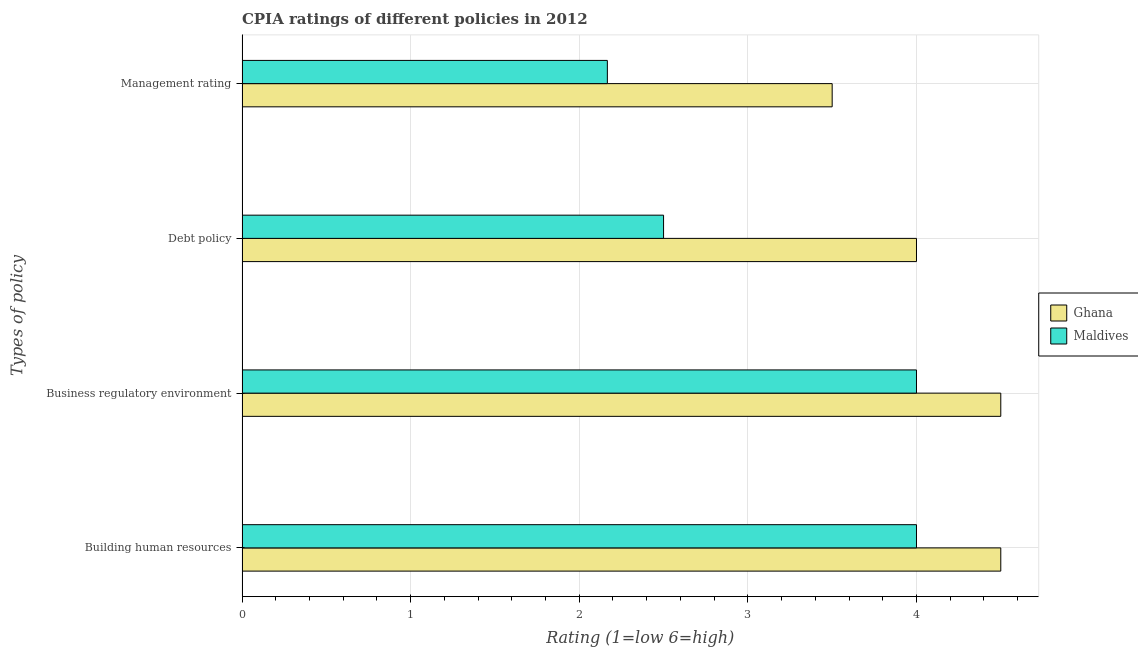How many different coloured bars are there?
Make the answer very short. 2. How many groups of bars are there?
Give a very brief answer. 4. Are the number of bars per tick equal to the number of legend labels?
Provide a short and direct response. Yes. How many bars are there on the 1st tick from the bottom?
Keep it short and to the point. 2. What is the label of the 3rd group of bars from the top?
Keep it short and to the point. Business regulatory environment. Across all countries, what is the maximum cpia rating of debt policy?
Ensure brevity in your answer.  4. In which country was the cpia rating of debt policy minimum?
Your answer should be compact. Maldives. What is the total cpia rating of business regulatory environment in the graph?
Your answer should be compact. 8.5. What is the difference between the cpia rating of business regulatory environment in Ghana and the cpia rating of management in Maldives?
Make the answer very short. 2.33. What is the average cpia rating of business regulatory environment per country?
Provide a succinct answer. 4.25. In how many countries, is the cpia rating of management greater than 3.2 ?
Give a very brief answer. 1. What is the ratio of the cpia rating of building human resources in Ghana to that in Maldives?
Provide a short and direct response. 1.12. What is the difference between the highest and the second highest cpia rating of management?
Provide a succinct answer. 1.33. What is the difference between the highest and the lowest cpia rating of business regulatory environment?
Keep it short and to the point. 0.5. Is the sum of the cpia rating of business regulatory environment in Ghana and Maldives greater than the maximum cpia rating of management across all countries?
Provide a short and direct response. Yes. What does the 2nd bar from the bottom in Management rating represents?
Provide a short and direct response. Maldives. How many bars are there?
Offer a terse response. 8. Are all the bars in the graph horizontal?
Offer a very short reply. Yes. What is the difference between two consecutive major ticks on the X-axis?
Provide a succinct answer. 1. Are the values on the major ticks of X-axis written in scientific E-notation?
Your answer should be compact. No. Does the graph contain any zero values?
Your response must be concise. No. Does the graph contain grids?
Offer a very short reply. Yes. How are the legend labels stacked?
Provide a succinct answer. Vertical. What is the title of the graph?
Ensure brevity in your answer.  CPIA ratings of different policies in 2012. What is the label or title of the Y-axis?
Offer a terse response. Types of policy. What is the Rating (1=low 6=high) in Ghana in Building human resources?
Provide a succinct answer. 4.5. What is the Rating (1=low 6=high) in Maldives in Building human resources?
Ensure brevity in your answer.  4. What is the Rating (1=low 6=high) in Ghana in Business regulatory environment?
Offer a terse response. 4.5. What is the Rating (1=low 6=high) in Maldives in Debt policy?
Provide a short and direct response. 2.5. What is the Rating (1=low 6=high) in Ghana in Management rating?
Keep it short and to the point. 3.5. What is the Rating (1=low 6=high) of Maldives in Management rating?
Make the answer very short. 2.17. Across all Types of policy, what is the minimum Rating (1=low 6=high) in Maldives?
Make the answer very short. 2.17. What is the total Rating (1=low 6=high) in Ghana in the graph?
Provide a succinct answer. 16.5. What is the total Rating (1=low 6=high) of Maldives in the graph?
Your answer should be very brief. 12.67. What is the difference between the Rating (1=low 6=high) in Ghana in Building human resources and that in Business regulatory environment?
Provide a succinct answer. 0. What is the difference between the Rating (1=low 6=high) of Maldives in Building human resources and that in Business regulatory environment?
Provide a succinct answer. 0. What is the difference between the Rating (1=low 6=high) of Ghana in Building human resources and that in Debt policy?
Keep it short and to the point. 0.5. What is the difference between the Rating (1=low 6=high) in Maldives in Building human resources and that in Management rating?
Offer a terse response. 1.83. What is the difference between the Rating (1=low 6=high) of Ghana in Business regulatory environment and that in Debt policy?
Ensure brevity in your answer.  0.5. What is the difference between the Rating (1=low 6=high) in Maldives in Business regulatory environment and that in Management rating?
Ensure brevity in your answer.  1.83. What is the difference between the Rating (1=low 6=high) in Ghana in Building human resources and the Rating (1=low 6=high) in Maldives in Management rating?
Provide a succinct answer. 2.33. What is the difference between the Rating (1=low 6=high) in Ghana in Business regulatory environment and the Rating (1=low 6=high) in Maldives in Debt policy?
Offer a terse response. 2. What is the difference between the Rating (1=low 6=high) in Ghana in Business regulatory environment and the Rating (1=low 6=high) in Maldives in Management rating?
Offer a very short reply. 2.33. What is the difference between the Rating (1=low 6=high) in Ghana in Debt policy and the Rating (1=low 6=high) in Maldives in Management rating?
Your answer should be compact. 1.83. What is the average Rating (1=low 6=high) of Ghana per Types of policy?
Give a very brief answer. 4.12. What is the average Rating (1=low 6=high) of Maldives per Types of policy?
Your response must be concise. 3.17. What is the difference between the Rating (1=low 6=high) in Ghana and Rating (1=low 6=high) in Maldives in Building human resources?
Make the answer very short. 0.5. What is the difference between the Rating (1=low 6=high) of Ghana and Rating (1=low 6=high) of Maldives in Business regulatory environment?
Offer a terse response. 0.5. What is the difference between the Rating (1=low 6=high) of Ghana and Rating (1=low 6=high) of Maldives in Management rating?
Give a very brief answer. 1.33. What is the ratio of the Rating (1=low 6=high) of Maldives in Building human resources to that in Business regulatory environment?
Give a very brief answer. 1. What is the ratio of the Rating (1=low 6=high) in Maldives in Building human resources to that in Debt policy?
Your answer should be compact. 1.6. What is the ratio of the Rating (1=low 6=high) of Ghana in Building human resources to that in Management rating?
Provide a short and direct response. 1.29. What is the ratio of the Rating (1=low 6=high) in Maldives in Building human resources to that in Management rating?
Give a very brief answer. 1.85. What is the ratio of the Rating (1=low 6=high) in Ghana in Business regulatory environment to that in Management rating?
Offer a terse response. 1.29. What is the ratio of the Rating (1=low 6=high) of Maldives in Business regulatory environment to that in Management rating?
Keep it short and to the point. 1.85. What is the ratio of the Rating (1=low 6=high) in Maldives in Debt policy to that in Management rating?
Your answer should be compact. 1.15. What is the difference between the highest and the second highest Rating (1=low 6=high) of Ghana?
Make the answer very short. 0. What is the difference between the highest and the second highest Rating (1=low 6=high) of Maldives?
Your answer should be very brief. 0. What is the difference between the highest and the lowest Rating (1=low 6=high) of Ghana?
Your answer should be very brief. 1. What is the difference between the highest and the lowest Rating (1=low 6=high) in Maldives?
Offer a very short reply. 1.83. 